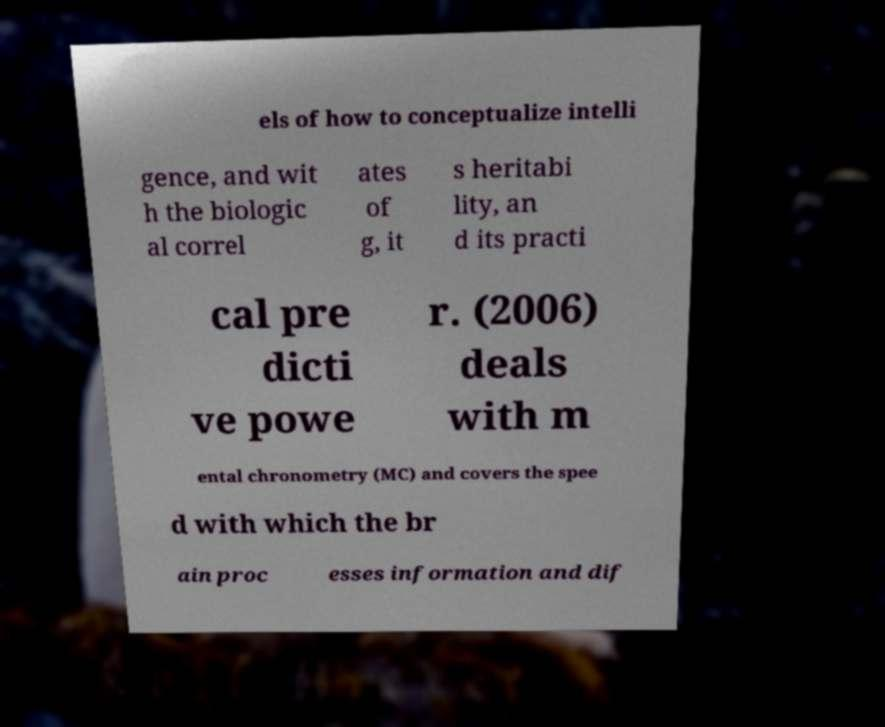Could you extract and type out the text from this image? els of how to conceptualize intelli gence, and wit h the biologic al correl ates of g, it s heritabi lity, an d its practi cal pre dicti ve powe r. (2006) deals with m ental chronometry (MC) and covers the spee d with which the br ain proc esses information and dif 